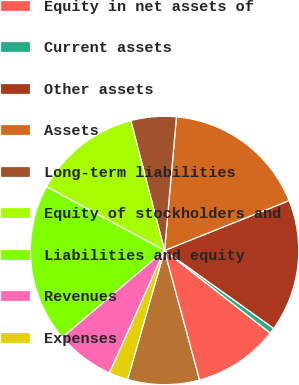Convert chart to OTSL. <chart><loc_0><loc_0><loc_500><loc_500><pie_chart><fcel>Investment in unconsolidated<fcel>Equity in net assets of<fcel>Current assets<fcel>Other assets<fcel>Assets<fcel>Long-term liabilities<fcel>Equity of stockholders and<fcel>Liabilities and equity<fcel>Revenues<fcel>Expenses<nl><fcel>8.65%<fcel>10.24%<fcel>0.68%<fcel>15.93%<fcel>17.52%<fcel>5.46%<fcel>13.07%<fcel>19.11%<fcel>7.06%<fcel>2.28%<nl></chart> 